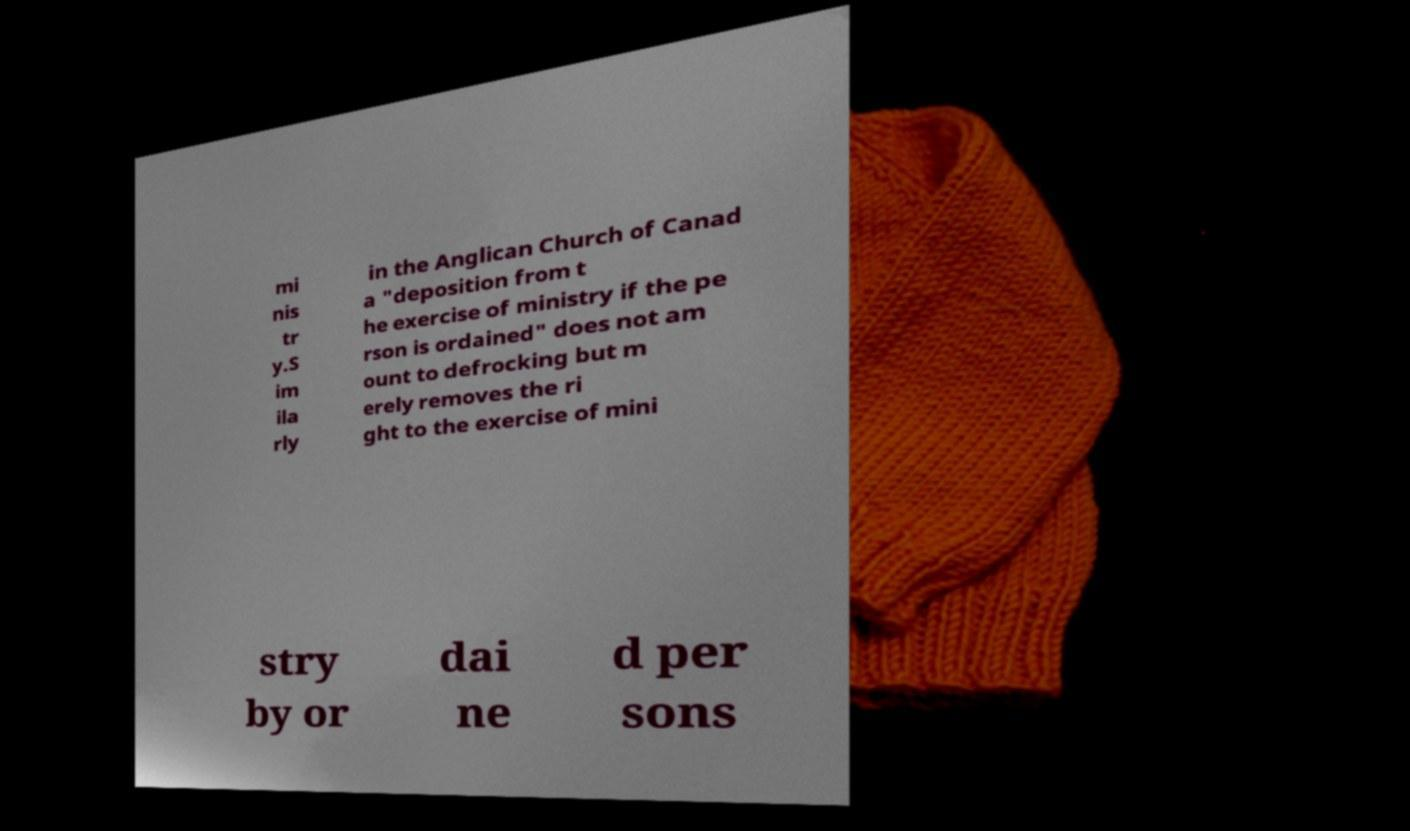For documentation purposes, I need the text within this image transcribed. Could you provide that? mi nis tr y.S im ila rly in the Anglican Church of Canad a "deposition from t he exercise of ministry if the pe rson is ordained" does not am ount to defrocking but m erely removes the ri ght to the exercise of mini stry by or dai ne d per sons 